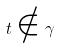Convert formula to latex. <formula><loc_0><loc_0><loc_500><loc_500>t \notin \gamma</formula> 